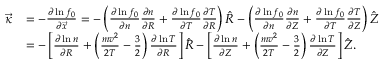<formula> <loc_0><loc_0><loc_500><loc_500>\begin{array} { r l } { \ V e c { \kappa } } & { = - \frac { \partial \ln f _ { 0 } } { \partial \ V e c { x } } = - \left ( \frac { \partial \ln f _ { 0 } } { \partial n } \frac { \partial n } { \partial R } + \frac { \partial \ln f _ { 0 } } { \partial T } \frac { \partial T } { \partial R } \right ) \hat { R } - \left ( \frac { \partial \ln f _ { 0 } } { \partial n } \frac { \partial n } { \partial Z } + \frac { \partial \ln f _ { 0 } } { \partial T } \frac { \partial T } { \partial Z } \right ) \hat { Z } } \\ & { = - \left [ \frac { \partial \ln n } { \partial R } + \left ( \frac { m v ^ { 2 } } { 2 T } - \frac { 3 } { 2 } \right ) \frac { \partial \ln T } { \partial R } \right ] \hat { R } - \left [ \frac { \partial \ln n } { \partial Z } + \left ( \frac { m v ^ { 2 } } { 2 T } - \frac { 3 } { 2 } \right ) \frac { \partial \ln T } { \partial Z } \right ] \hat { Z } . } \end{array}</formula> 